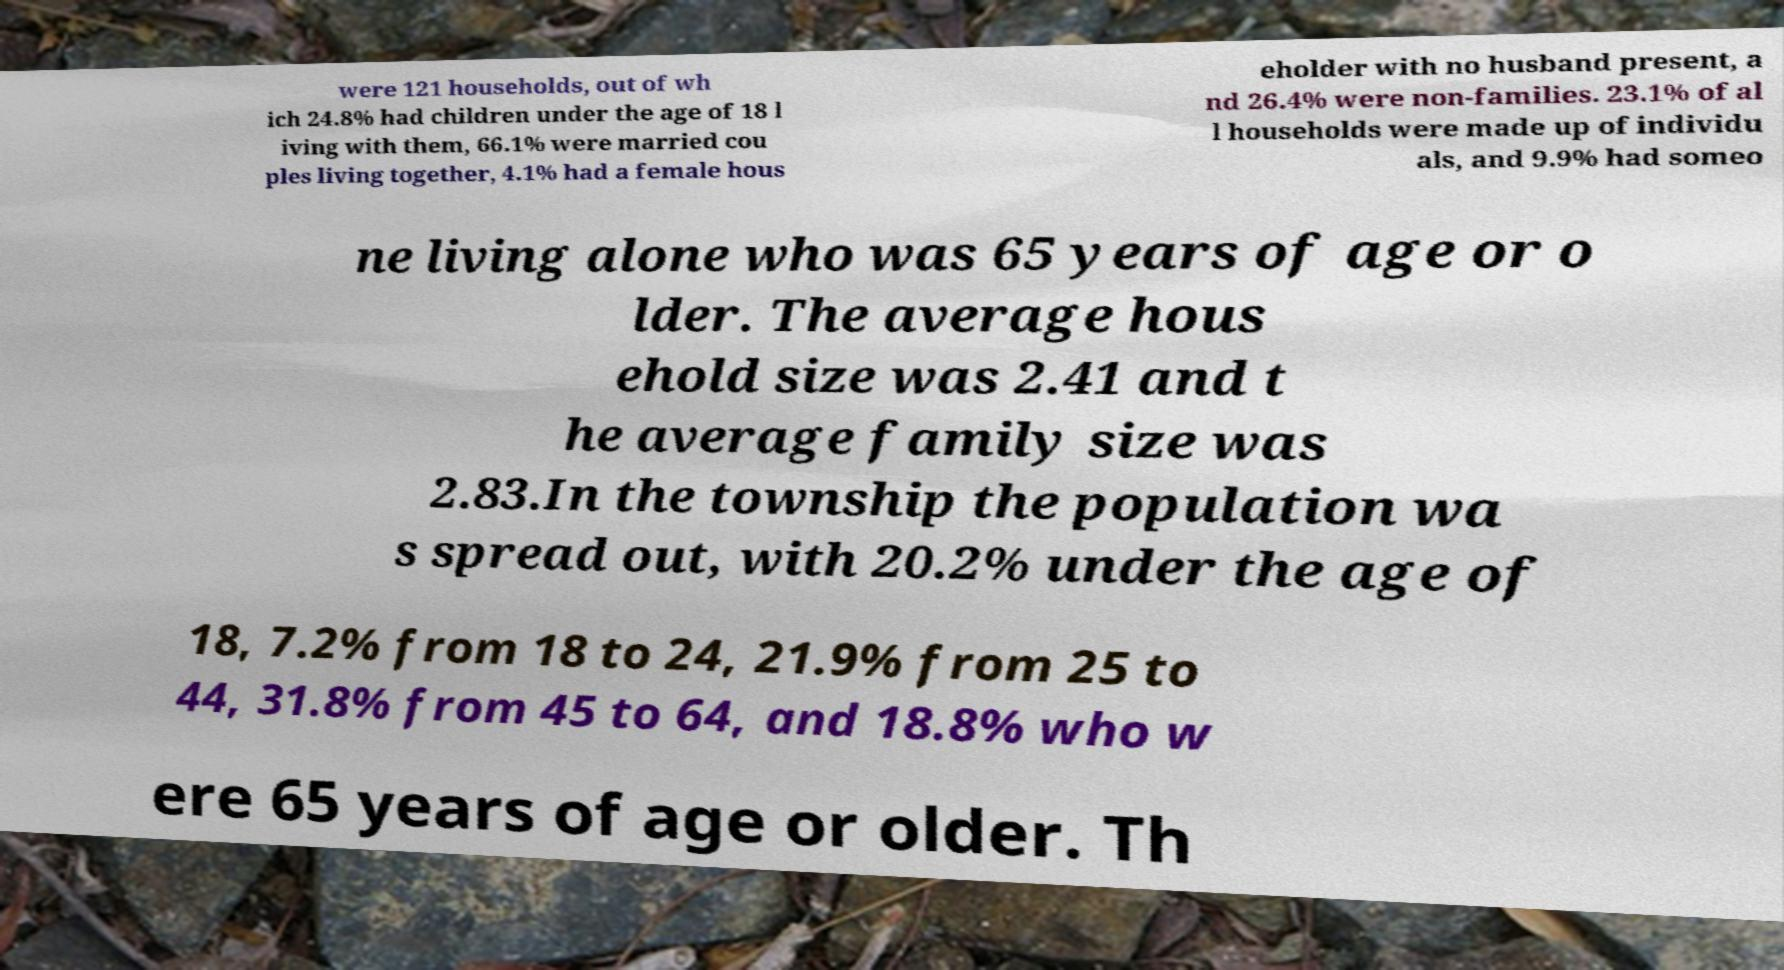Can you read and provide the text displayed in the image?This photo seems to have some interesting text. Can you extract and type it out for me? were 121 households, out of wh ich 24.8% had children under the age of 18 l iving with them, 66.1% were married cou ples living together, 4.1% had a female hous eholder with no husband present, a nd 26.4% were non-families. 23.1% of al l households were made up of individu als, and 9.9% had someo ne living alone who was 65 years of age or o lder. The average hous ehold size was 2.41 and t he average family size was 2.83.In the township the population wa s spread out, with 20.2% under the age of 18, 7.2% from 18 to 24, 21.9% from 25 to 44, 31.8% from 45 to 64, and 18.8% who w ere 65 years of age or older. Th 